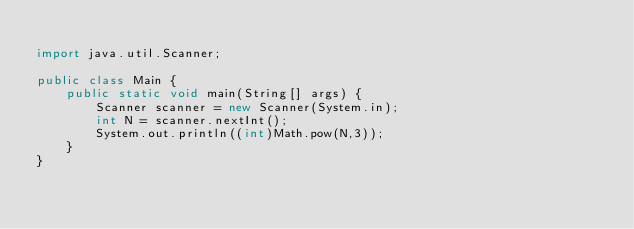Convert code to text. <code><loc_0><loc_0><loc_500><loc_500><_Java_>
import java.util.Scanner;

public class Main {
    public static void main(String[] args) {
        Scanner scanner = new Scanner(System.in);
        int N = scanner.nextInt();
        System.out.println((int)Math.pow(N,3));
    }
}
</code> 